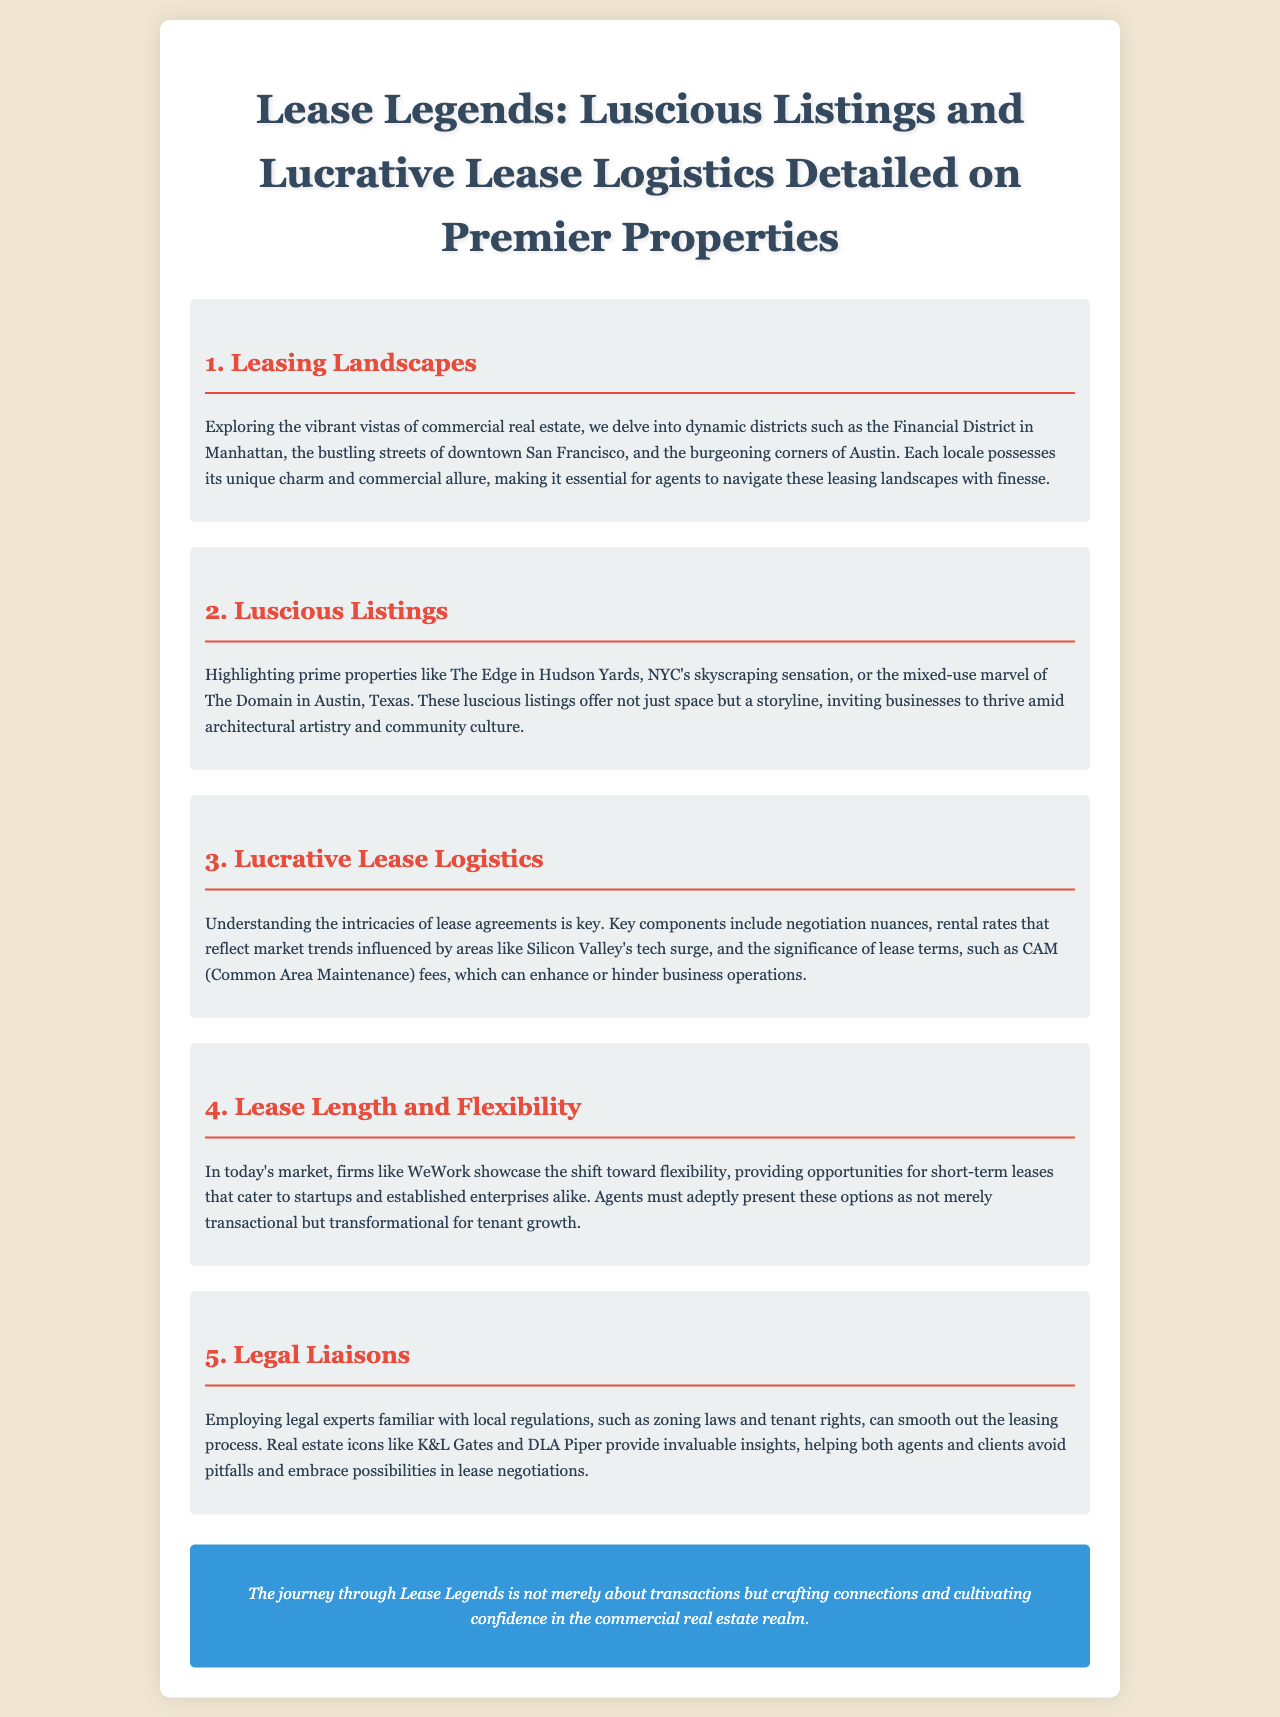What are the dynamic districts mentioned for leasing landscapes? The document lists the Financial District in Manhattan, downtown San Francisco, and the burgeoning corners of Austin as dynamic districts in commercial real estate.
Answer: Financial District, downtown San Francisco, Austin What is one of the prime properties highlighted as a luscious listing? The listing mentions "The Edge in Hudson Yards, NYC's skyscraping sensation" as a prime property.
Answer: The Edge in Hudson Yards What does CAM stand for in lease logistics? The section on Lucrative Lease Logistics discusses the significance of lease terms, such as CAM, which stands for Common Area Maintenance.
Answer: Common Area Maintenance Which company showcases the shift toward flexibility in lease length? In the Lease Length and Flexibility section, WeWork is mentioned as a company showcasing this shift in the market.
Answer: WeWork Who are two of the legal experts mentioned for lease negotiations? The Legal Liaisons section refers to K&L Gates and DLA Piper as legal experts providing insights in the leasing process.
Answer: K&L Gates, DLA Piper 